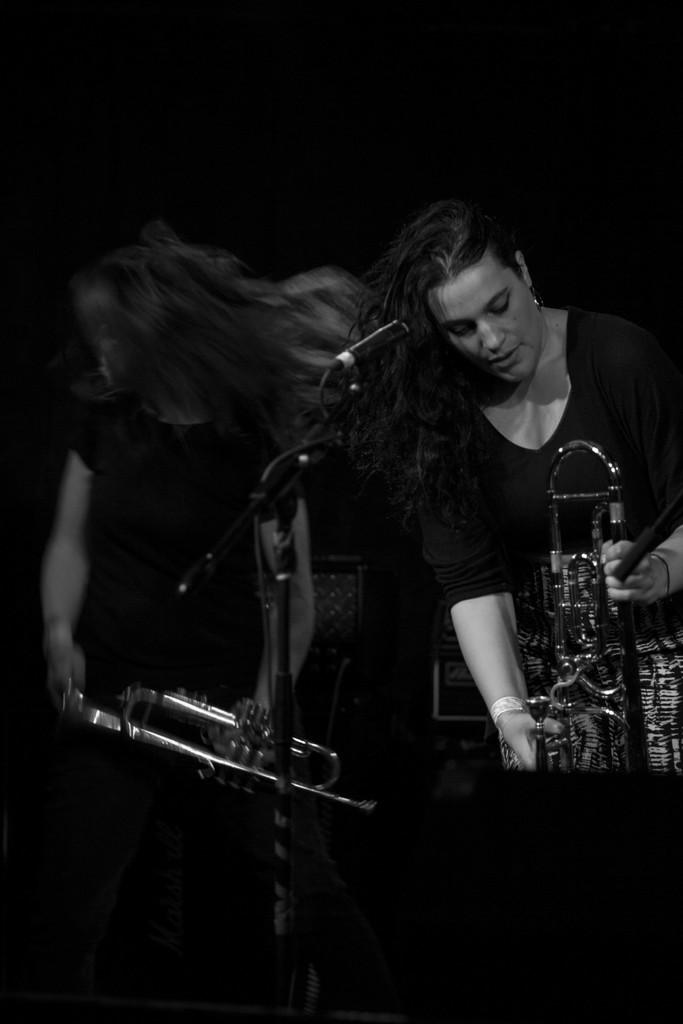Who is present in the image? There are women in the image. What are the women holding in the image? The women are holding trumpets. What device is visible in the image that is used for amplifying sound? There is a microphone in the image. What is the color of the background in the image? The background of the image is black. What type of bone can be seen in the image? There is no bone present in the image. How many cattle are visible in the image? There are no cattle present in the image. 